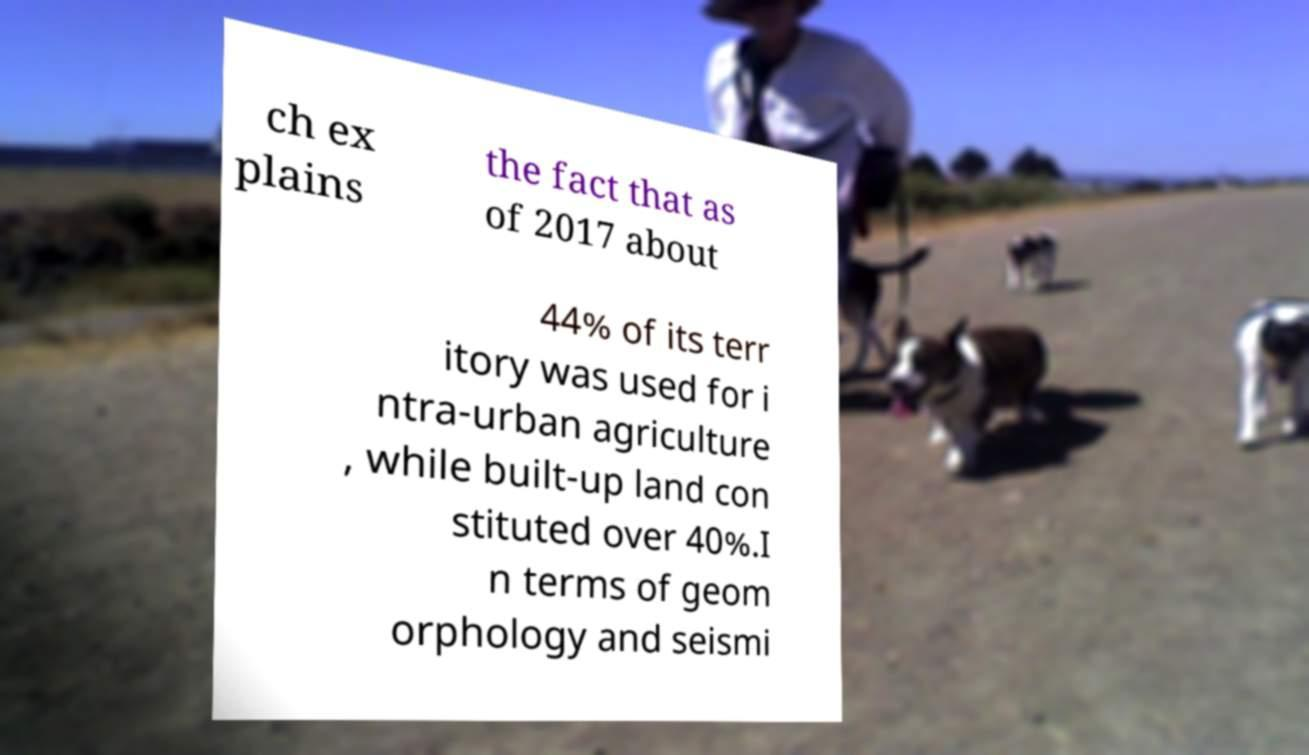For documentation purposes, I need the text within this image transcribed. Could you provide that? ch ex plains the fact that as of 2017 about 44% of its terr itory was used for i ntra-urban agriculture , while built-up land con stituted over 40%.I n terms of geom orphology and seismi 